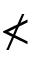<formula> <loc_0><loc_0><loc_500><loc_500>\nless</formula> 